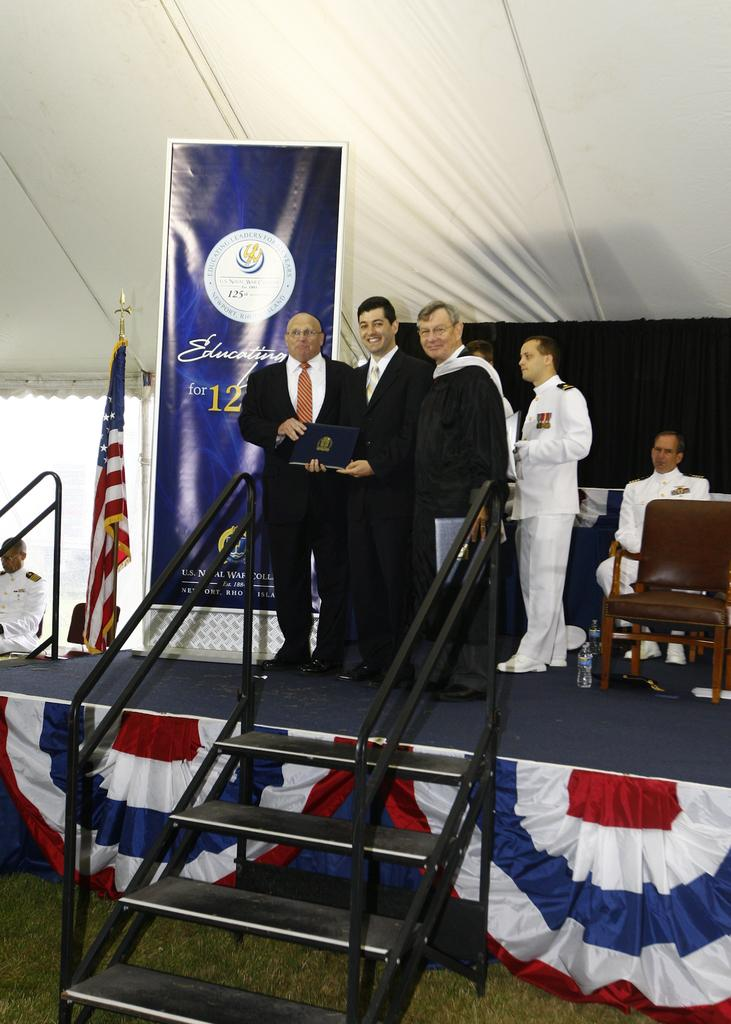What are the people in the image doing? The people are standing on a stage in the image. What can be seen hanging or displayed in the image? There is a banner and a flag in the image. What type of furniture is present in the image? There is a chair in the image. What architectural feature is visible in the image? There is a staircase in the image. What type of yoke is being used by the people on the stage in the image? There is no yoke present in the image; the people are simply standing on the stage. How many rings can be seen on the hands of the people in the image? There is no information about rings on the hands of the people in the image, as the focus is on their standing position on the stage. 